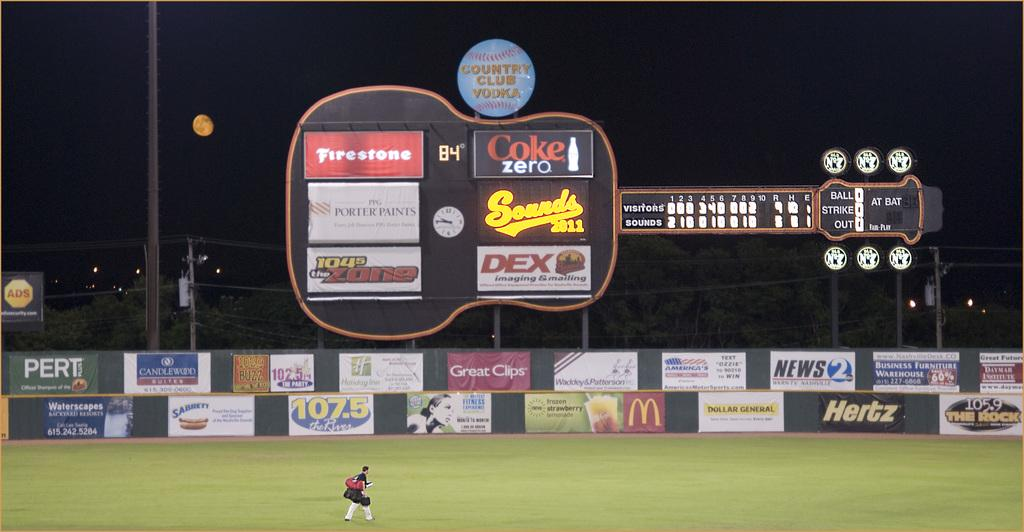<image>
Describe the image concisely. A scoreboard with Coke, DEX and Firestone ads. 